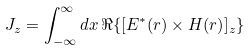Convert formula to latex. <formula><loc_0><loc_0><loc_500><loc_500>J _ { z } = \int _ { - \infty } ^ { \infty } d x \, \Re \{ [ { E ^ { * } ( r ) } \times { H ( r ) } ] _ { z } \}</formula> 